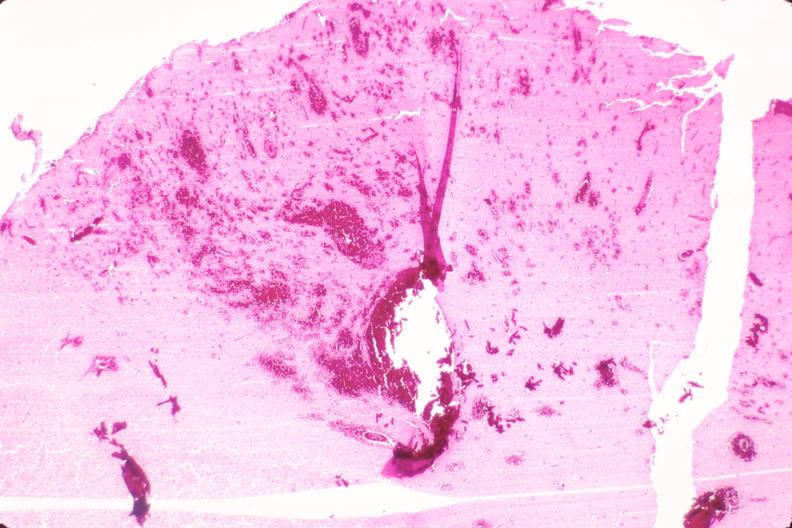where is this?
Answer the question using a single word or phrase. Nervous 